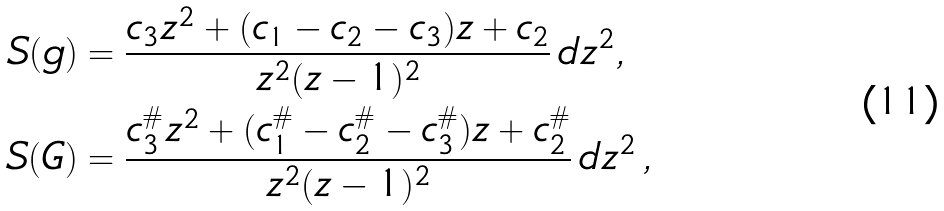Convert formula to latex. <formula><loc_0><loc_0><loc_500><loc_500>S ( g ) & = \frac { c _ { 3 } z ^ { 2 } + ( c _ { 1 } - c _ { 2 } - c _ { 3 } ) z + c _ { 2 } } { z ^ { 2 } ( z - 1 ) ^ { 2 } } \, d z ^ { 2 } , \\ S ( G ) & = \frac { c _ { 3 } ^ { \# } z ^ { 2 } + ( c _ { 1 } ^ { \# } - c _ { 2 } ^ { \# } - c _ { 3 } ^ { \# } ) z + c _ { 2 } ^ { \# } } { z ^ { 2 } ( z - 1 ) ^ { 2 } } \, d z ^ { 2 } \, ,</formula> 